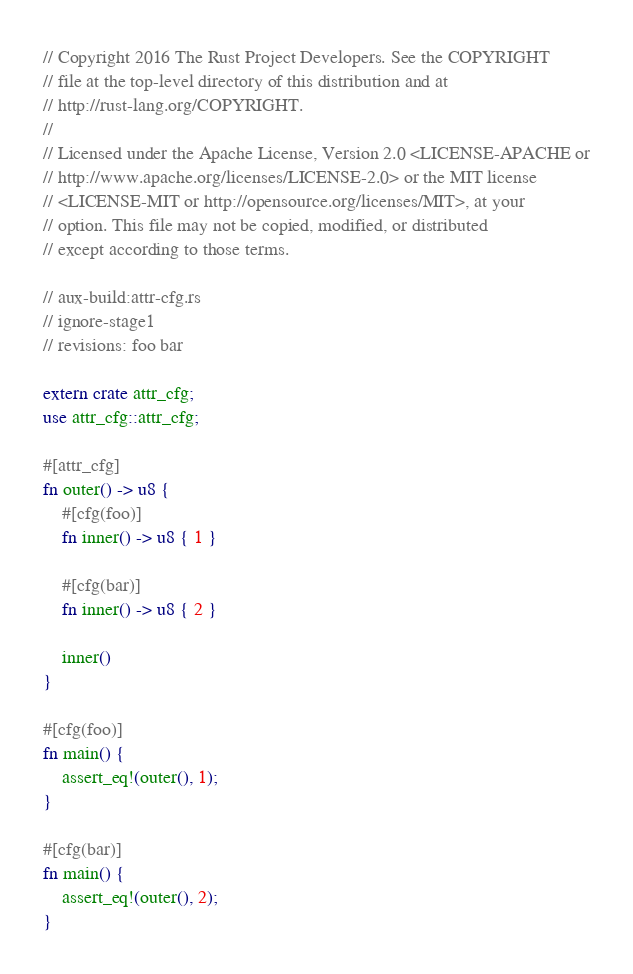<code> <loc_0><loc_0><loc_500><loc_500><_Rust_>// Copyright 2016 The Rust Project Developers. See the COPYRIGHT
// file at the top-level directory of this distribution and at
// http://rust-lang.org/COPYRIGHT.
//
// Licensed under the Apache License, Version 2.0 <LICENSE-APACHE or
// http://www.apache.org/licenses/LICENSE-2.0> or the MIT license
// <LICENSE-MIT or http://opensource.org/licenses/MIT>, at your
// option. This file may not be copied, modified, or distributed
// except according to those terms.

// aux-build:attr-cfg.rs
// ignore-stage1
// revisions: foo bar

extern crate attr_cfg;
use attr_cfg::attr_cfg;

#[attr_cfg]
fn outer() -> u8 {
    #[cfg(foo)]
    fn inner() -> u8 { 1 }

    #[cfg(bar)]
    fn inner() -> u8 { 2 }

    inner()
}

#[cfg(foo)]
fn main() {
    assert_eq!(outer(), 1);
}

#[cfg(bar)]
fn main() {
    assert_eq!(outer(), 2);
}
</code> 